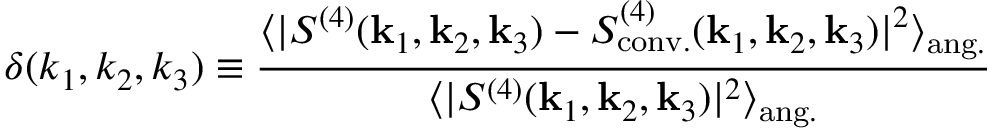Convert formula to latex. <formula><loc_0><loc_0><loc_500><loc_500>\delta ( k _ { 1 } , k _ { 2 } , k _ { 3 } ) \equiv \frac { \langle | S ^ { ( 4 ) } ( k _ { 1 } , k _ { 2 } , k _ { 3 } ) - S _ { c o n v . } ^ { ( 4 ) } ( k _ { 1 } , k _ { 2 } , k _ { 3 } ) | ^ { 2 } \rangle _ { a n g . } } { \langle | S ^ { ( 4 ) } ( k _ { 1 } , k _ { 2 } , k _ { 3 } ) | ^ { 2 } \rangle _ { a n g . } }</formula> 